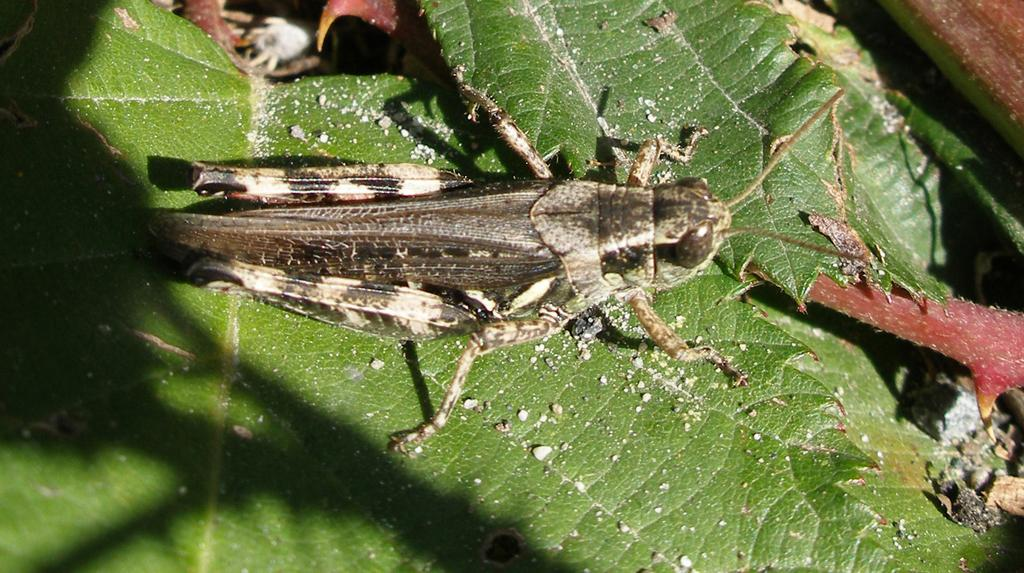What type of vegetation can be seen in the image? There are leaves in the image. Can you describe the insect in the image? There is an insect above the leaves in the image. What type of pest can be seen gripping the leaves in the image? There is no pest present in the image, and the insect is not gripping the leaves. 